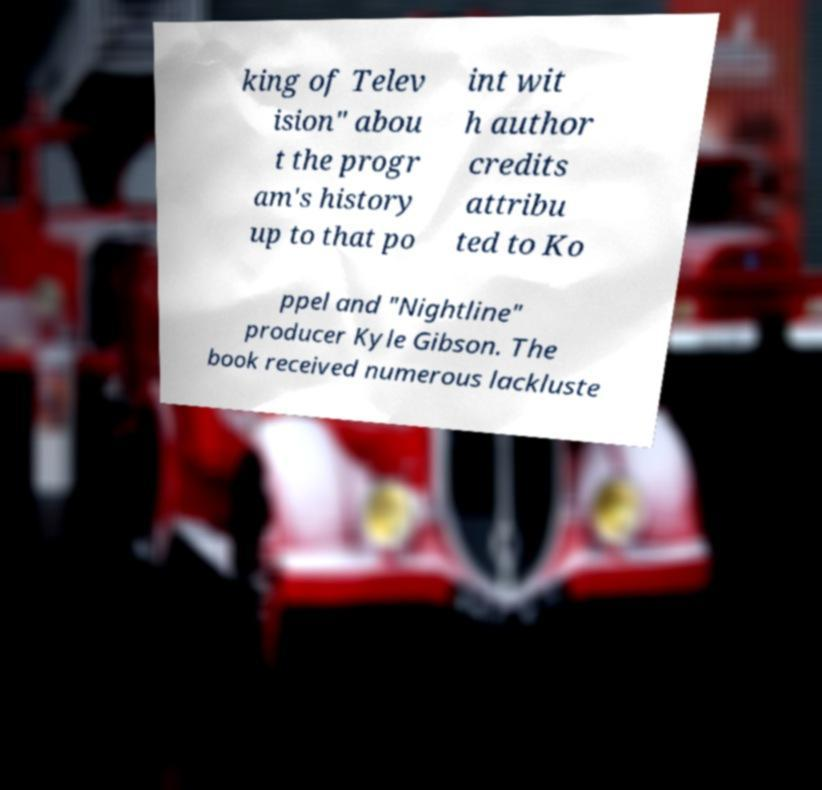Please read and relay the text visible in this image. What does it say? king of Telev ision" abou t the progr am's history up to that po int wit h author credits attribu ted to Ko ppel and "Nightline" producer Kyle Gibson. The book received numerous lackluste 